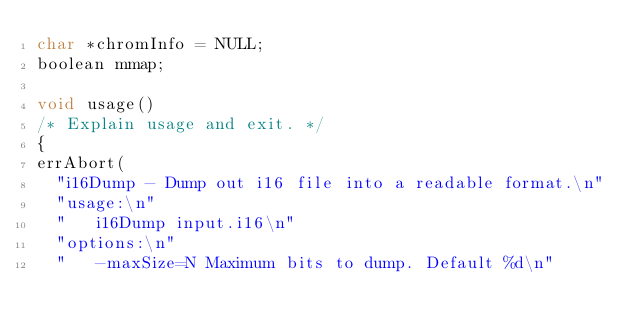Convert code to text. <code><loc_0><loc_0><loc_500><loc_500><_C_>char *chromInfo = NULL;
boolean mmap;

void usage()
/* Explain usage and exit. */
{
errAbort(
  "i16Dump - Dump out i16 file into a readable format.\n"
  "usage:\n"
  "   i16Dump input.i16\n"
  "options:\n"
  "   -maxSize=N Maximum bits to dump. Default %d\n"</code> 